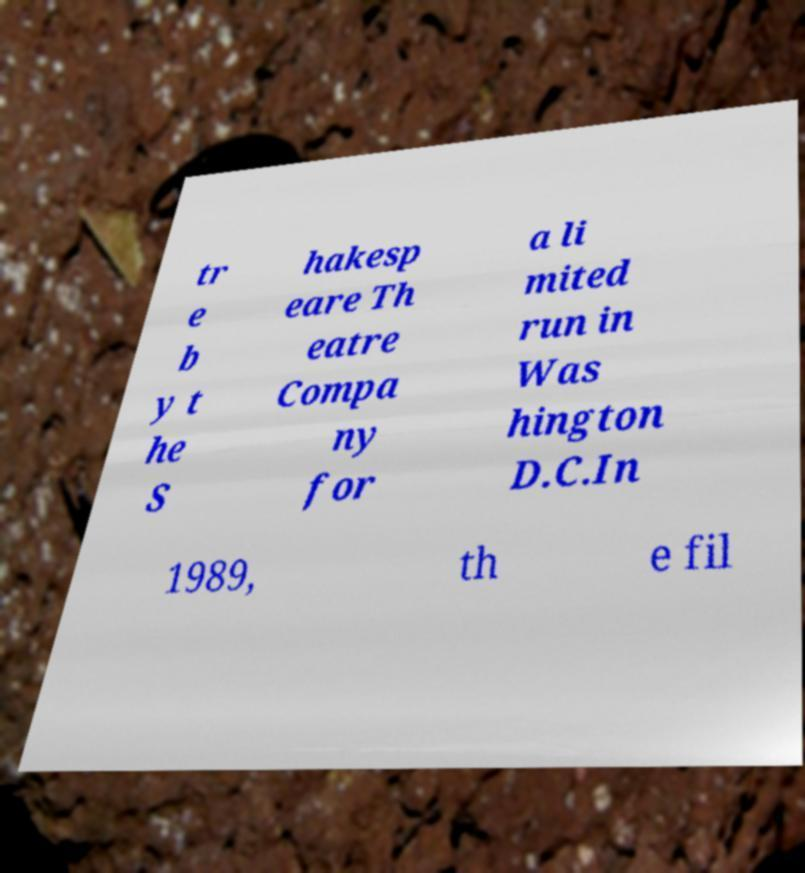Can you accurately transcribe the text from the provided image for me? tr e b y t he S hakesp eare Th eatre Compa ny for a li mited run in Was hington D.C.In 1989, th e fil 